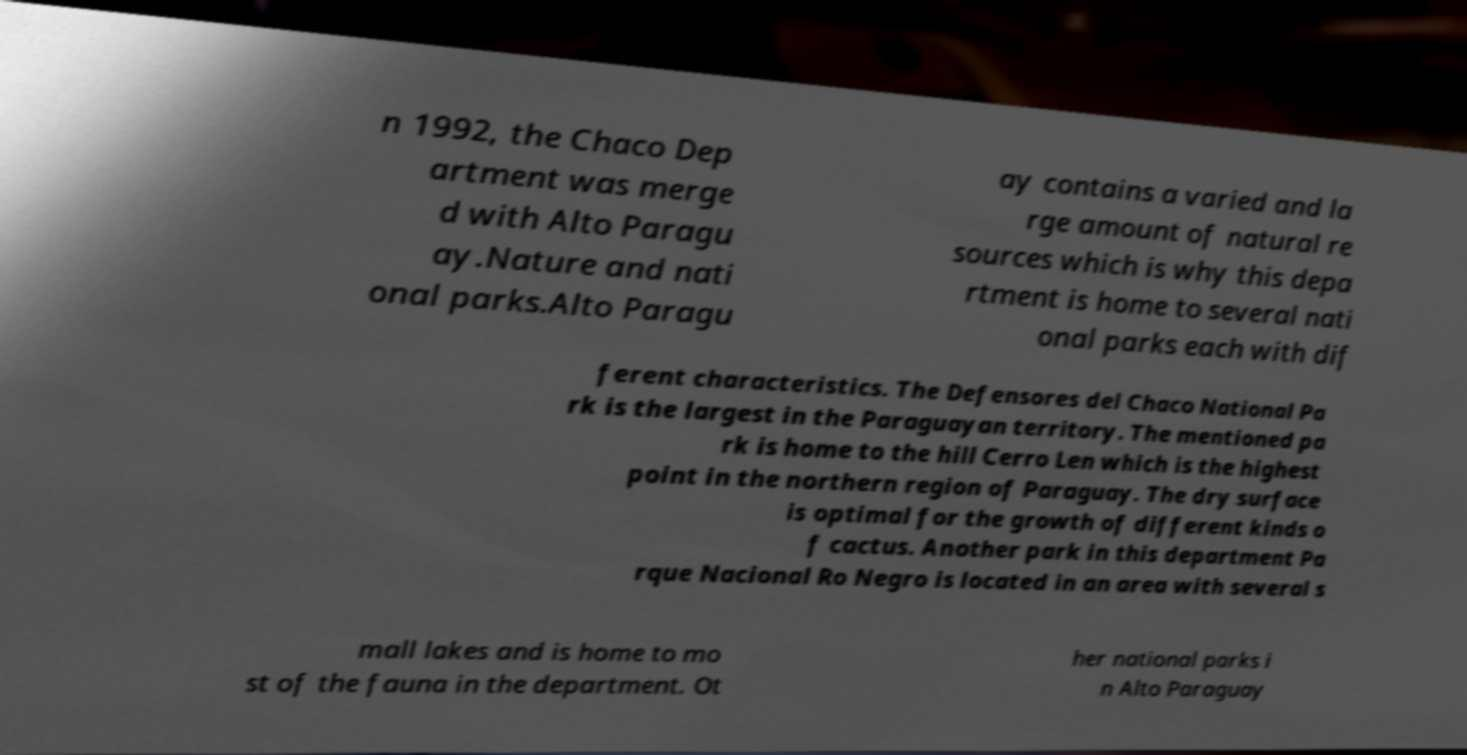Please read and relay the text visible in this image. What does it say? n 1992, the Chaco Dep artment was merge d with Alto Paragu ay.Nature and nati onal parks.Alto Paragu ay contains a varied and la rge amount of natural re sources which is why this depa rtment is home to several nati onal parks each with dif ferent characteristics. The Defensores del Chaco National Pa rk is the largest in the Paraguayan territory. The mentioned pa rk is home to the hill Cerro Len which is the highest point in the northern region of Paraguay. The dry surface is optimal for the growth of different kinds o f cactus. Another park in this department Pa rque Nacional Ro Negro is located in an area with several s mall lakes and is home to mo st of the fauna in the department. Ot her national parks i n Alto Paraguay 